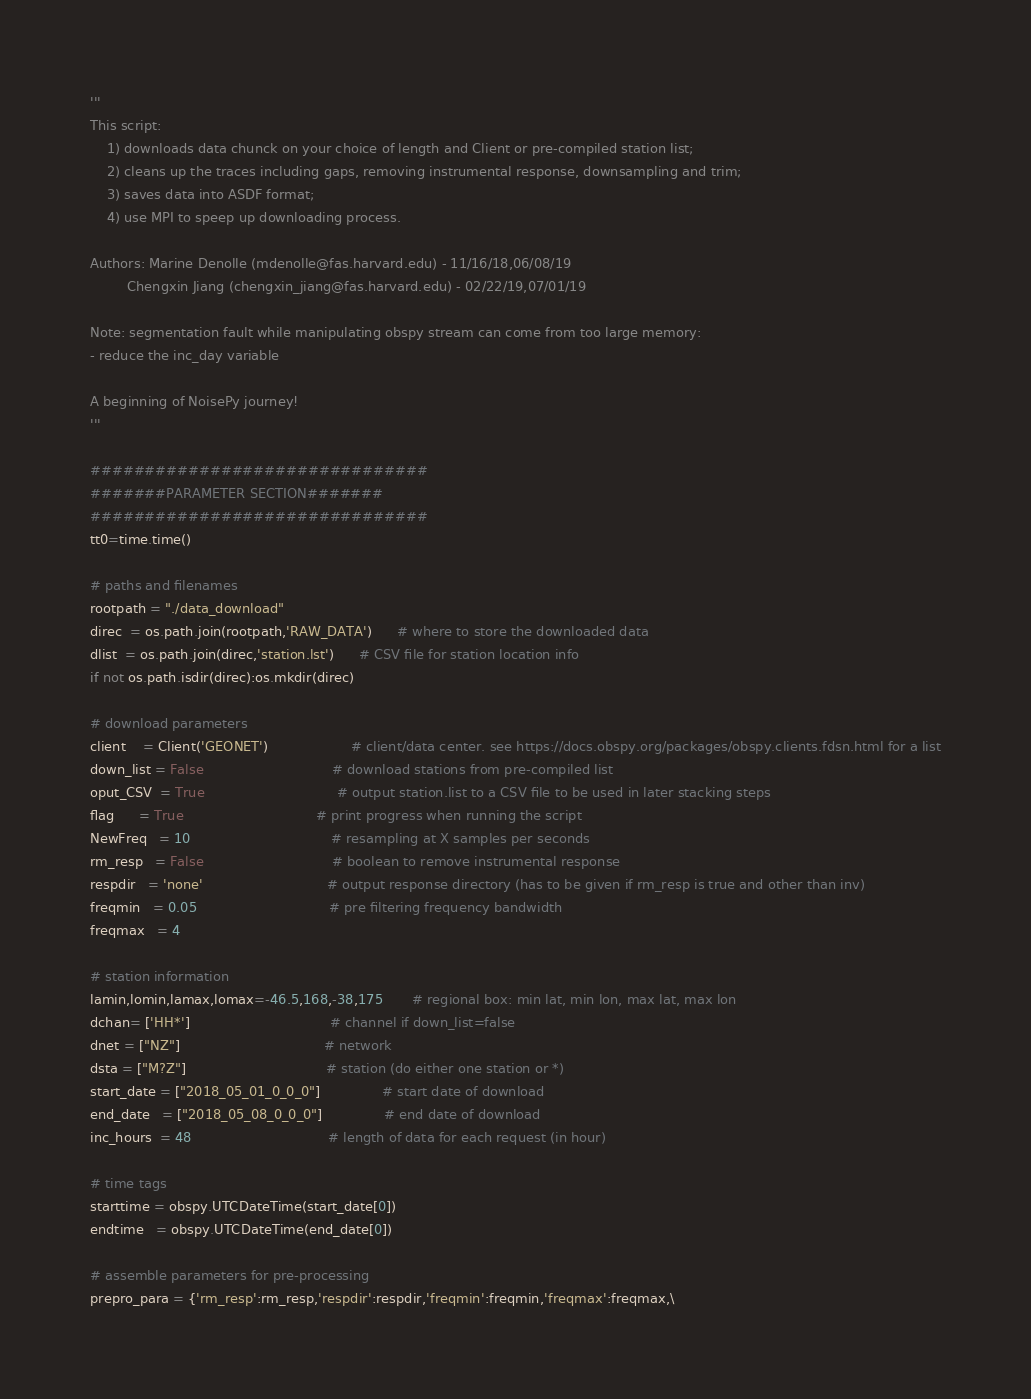<code> <loc_0><loc_0><loc_500><loc_500><_Python_>'''
This script:
    1) downloads data chunck on your choice of length and Client or pre-compiled station list;
    2) cleans up the traces including gaps, removing instrumental response, downsampling and trim;
    3) saves data into ASDF format;
    4) use MPI to speep up downloading process.

Authors: Marine Denolle (mdenolle@fas.harvard.edu) - 11/16/18,06/08/19
         Chengxin Jiang (chengxin_jiang@fas.harvard.edu) - 02/22/19,07/01/19
         
Note: segmentation fault while manipulating obspy stream can come from too large memory: 
- reduce the inc_day variable

A beginning of NoisePy journey! 
'''

###############################
#######PARAMETER SECTION#######
###############################
tt0=time.time()

# paths and filenames
rootpath = "./data_download"         
direc  = os.path.join(rootpath,'RAW_DATA')      # where to store the downloaded data
dlist  = os.path.join(direc,'station.lst')      # CSV file for station location info
if not os.path.isdir(direc):os.mkdir(direc)

# download parameters
client    = Client('GEONET')                    # client/data center. see https://docs.obspy.org/packages/obspy.clients.fdsn.html for a list
down_list = False                               # download stations from pre-compiled list
oput_CSV  = True                                # output station.list to a CSV file to be used in later stacking steps
flag      = True                                # print progress when running the script
NewFreq   = 10                                  # resampling at X samples per seconds 
rm_resp   = False                               # boolean to remove instrumental response
respdir   = 'none'                              # output response directory (has to be given if rm_resp is true and other than inv)
freqmin   = 0.05                                # pre filtering frequency bandwidth
freqmax   = 4

# station information 
lamin,lomin,lamax,lomax=-46.5,168,-38,175       # regional box: min lat, min lon, max lat, max lon
dchan= ['HH*']                                  # channel if down_list=false
dnet = ["NZ"]                                   # network  
dsta = ["M?Z"]                                  # station (do either one station or *)
start_date = ["2018_05_01_0_0_0"]               # start date of download
end_date   = ["2018_05_08_0_0_0"]               # end date of download
inc_hours  = 48                                 # length of data for each request (in hour)

# time tags
starttime = obspy.UTCDateTime(start_date[0])       
endtime   = obspy.UTCDateTime(end_date[0])

# assemble parameters for pre-processing
prepro_para = {'rm_resp':rm_resp,'respdir':respdir,'freqmin':freqmin,'freqmax':freqmax,\</code> 